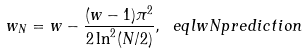<formula> <loc_0><loc_0><loc_500><loc_500>w _ { N } = w - \frac { ( w - 1 ) \pi ^ { 2 } } { 2 \ln ^ { 2 } ( N / 2 ) } , \ e q l { w N p r e d i c t i o n }</formula> 